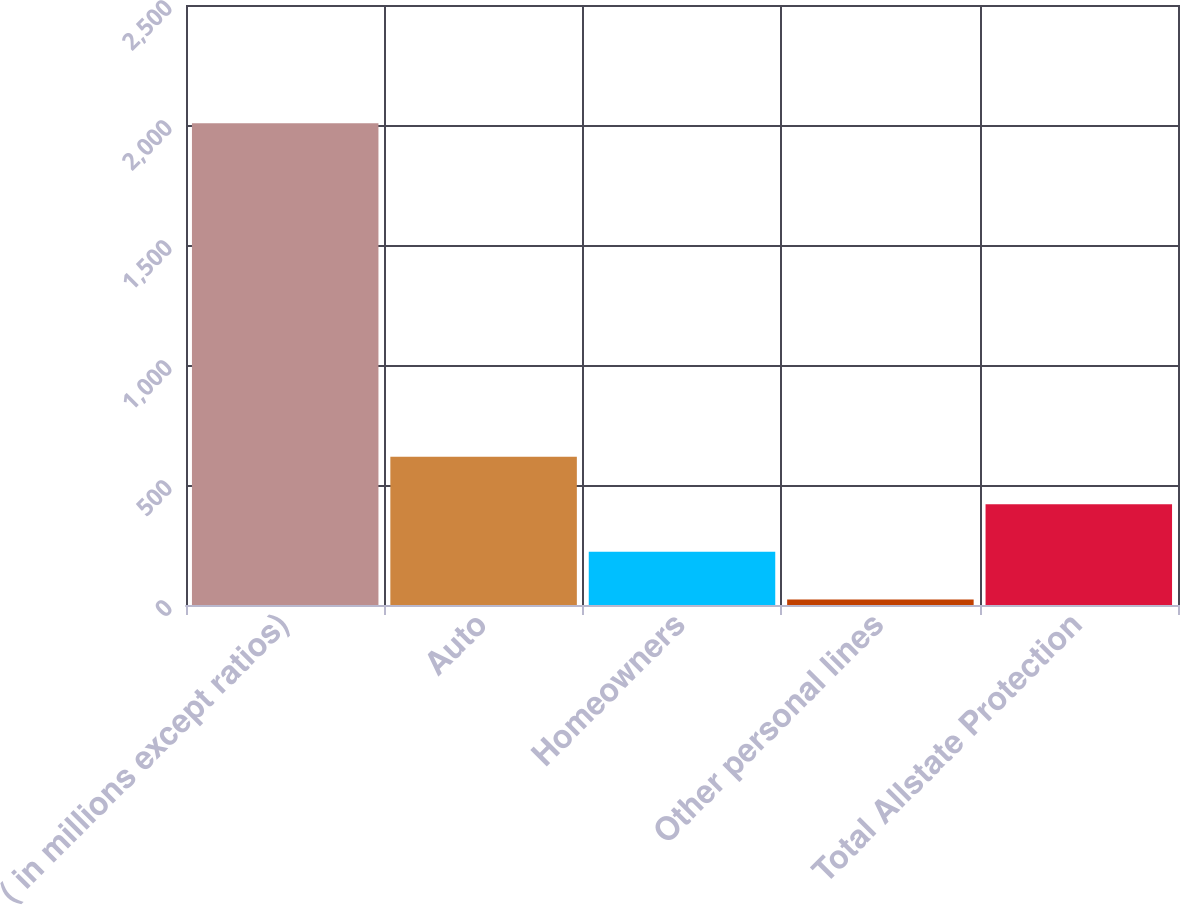Convert chart. <chart><loc_0><loc_0><loc_500><loc_500><bar_chart><fcel>( in millions except ratios)<fcel>Auto<fcel>Homeowners<fcel>Other personal lines<fcel>Total Allstate Protection<nl><fcel>2007<fcel>618.2<fcel>221.4<fcel>23<fcel>419.8<nl></chart> 